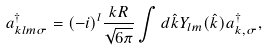<formula> <loc_0><loc_0><loc_500><loc_500>a ^ { \dagger } _ { k l m \sigma } = ( - i ) ^ { l } \frac { k R } { \sqrt { 6 \pi } } \int d \hat { k } Y _ { l m } ( \hat { k } ) a ^ { \dagger } _ { { k } , \sigma } ,</formula> 